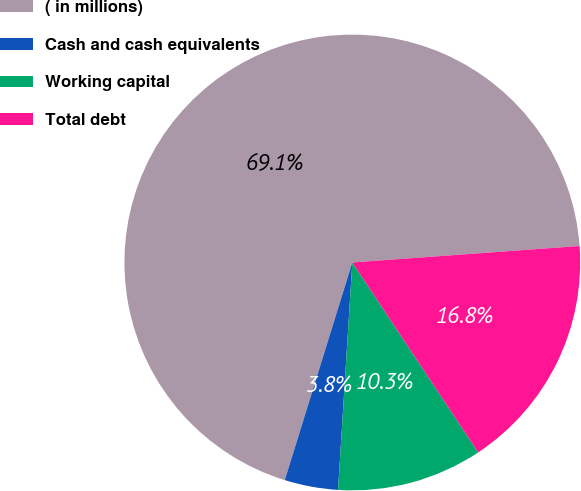Convert chart. <chart><loc_0><loc_0><loc_500><loc_500><pie_chart><fcel>( in millions)<fcel>Cash and cash equivalents<fcel>Working capital<fcel>Total debt<nl><fcel>69.06%<fcel>3.79%<fcel>10.31%<fcel>16.84%<nl></chart> 